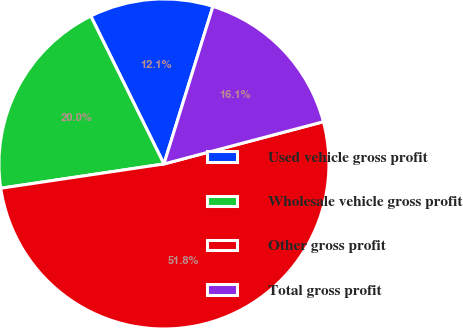Convert chart to OTSL. <chart><loc_0><loc_0><loc_500><loc_500><pie_chart><fcel>Used vehicle gross profit<fcel>Wholesale vehicle gross profit<fcel>Other gross profit<fcel>Total gross profit<nl><fcel>12.11%<fcel>20.04%<fcel>51.77%<fcel>16.08%<nl></chart> 